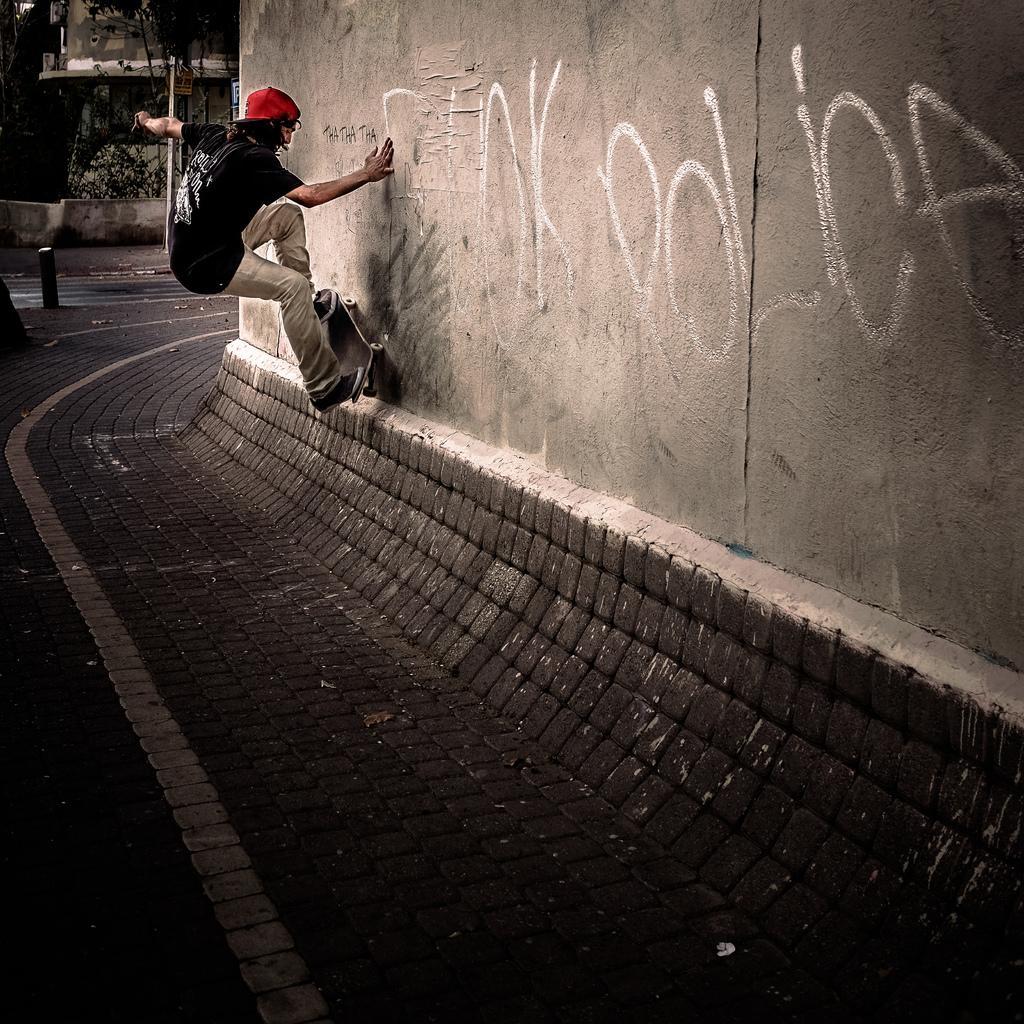Could you give a brief overview of what you see in this image? In this image we can see a person on the skateboard wearing a red color cap. To the right side of the image there is wall. At the bottom of the image there is road. In the background of the image there are trees, house. 